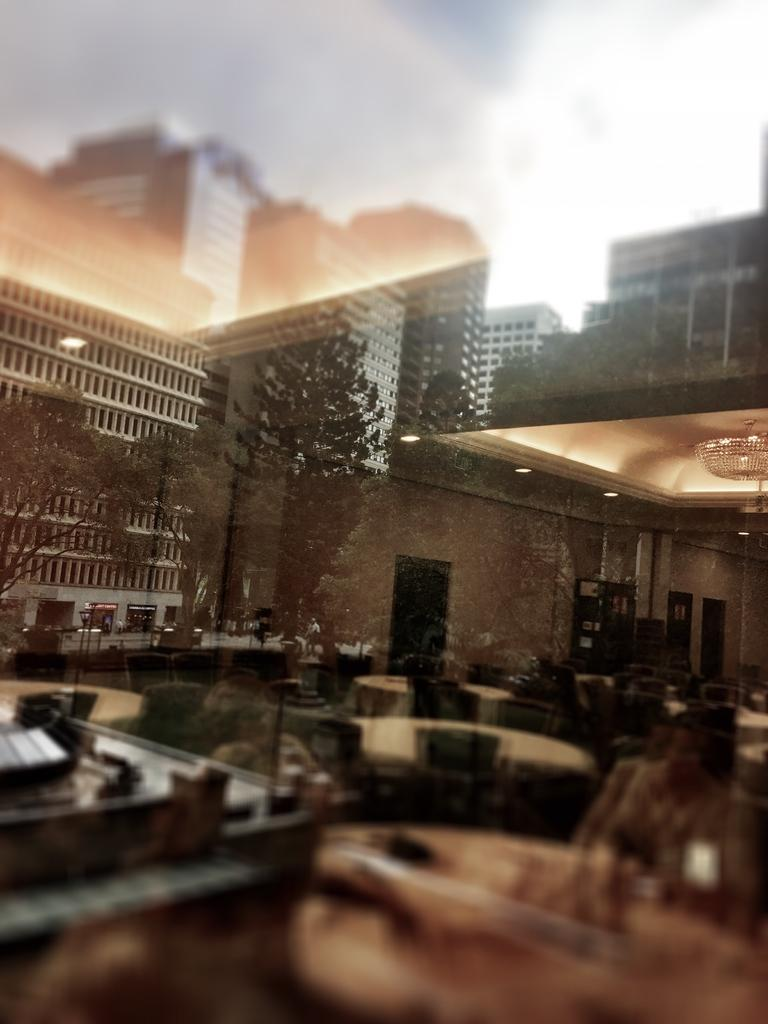What type of structures can be seen in the image? There are buildings in the image. What natural elements are present in the image? There are trees in the image. What type of furniture is visible in the image? There are tables and chairs in the image. What is visible in the background of the image? The sky is visible in the image, and clouds are present in the sky. Can you tell me how many cherries are on the sidewalk in the image? There are no cherries or sidewalks present in the image. What type of minister is depicted in the image? There is no minister present in the image. 